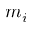<formula> <loc_0><loc_0><loc_500><loc_500>m _ { i }</formula> 